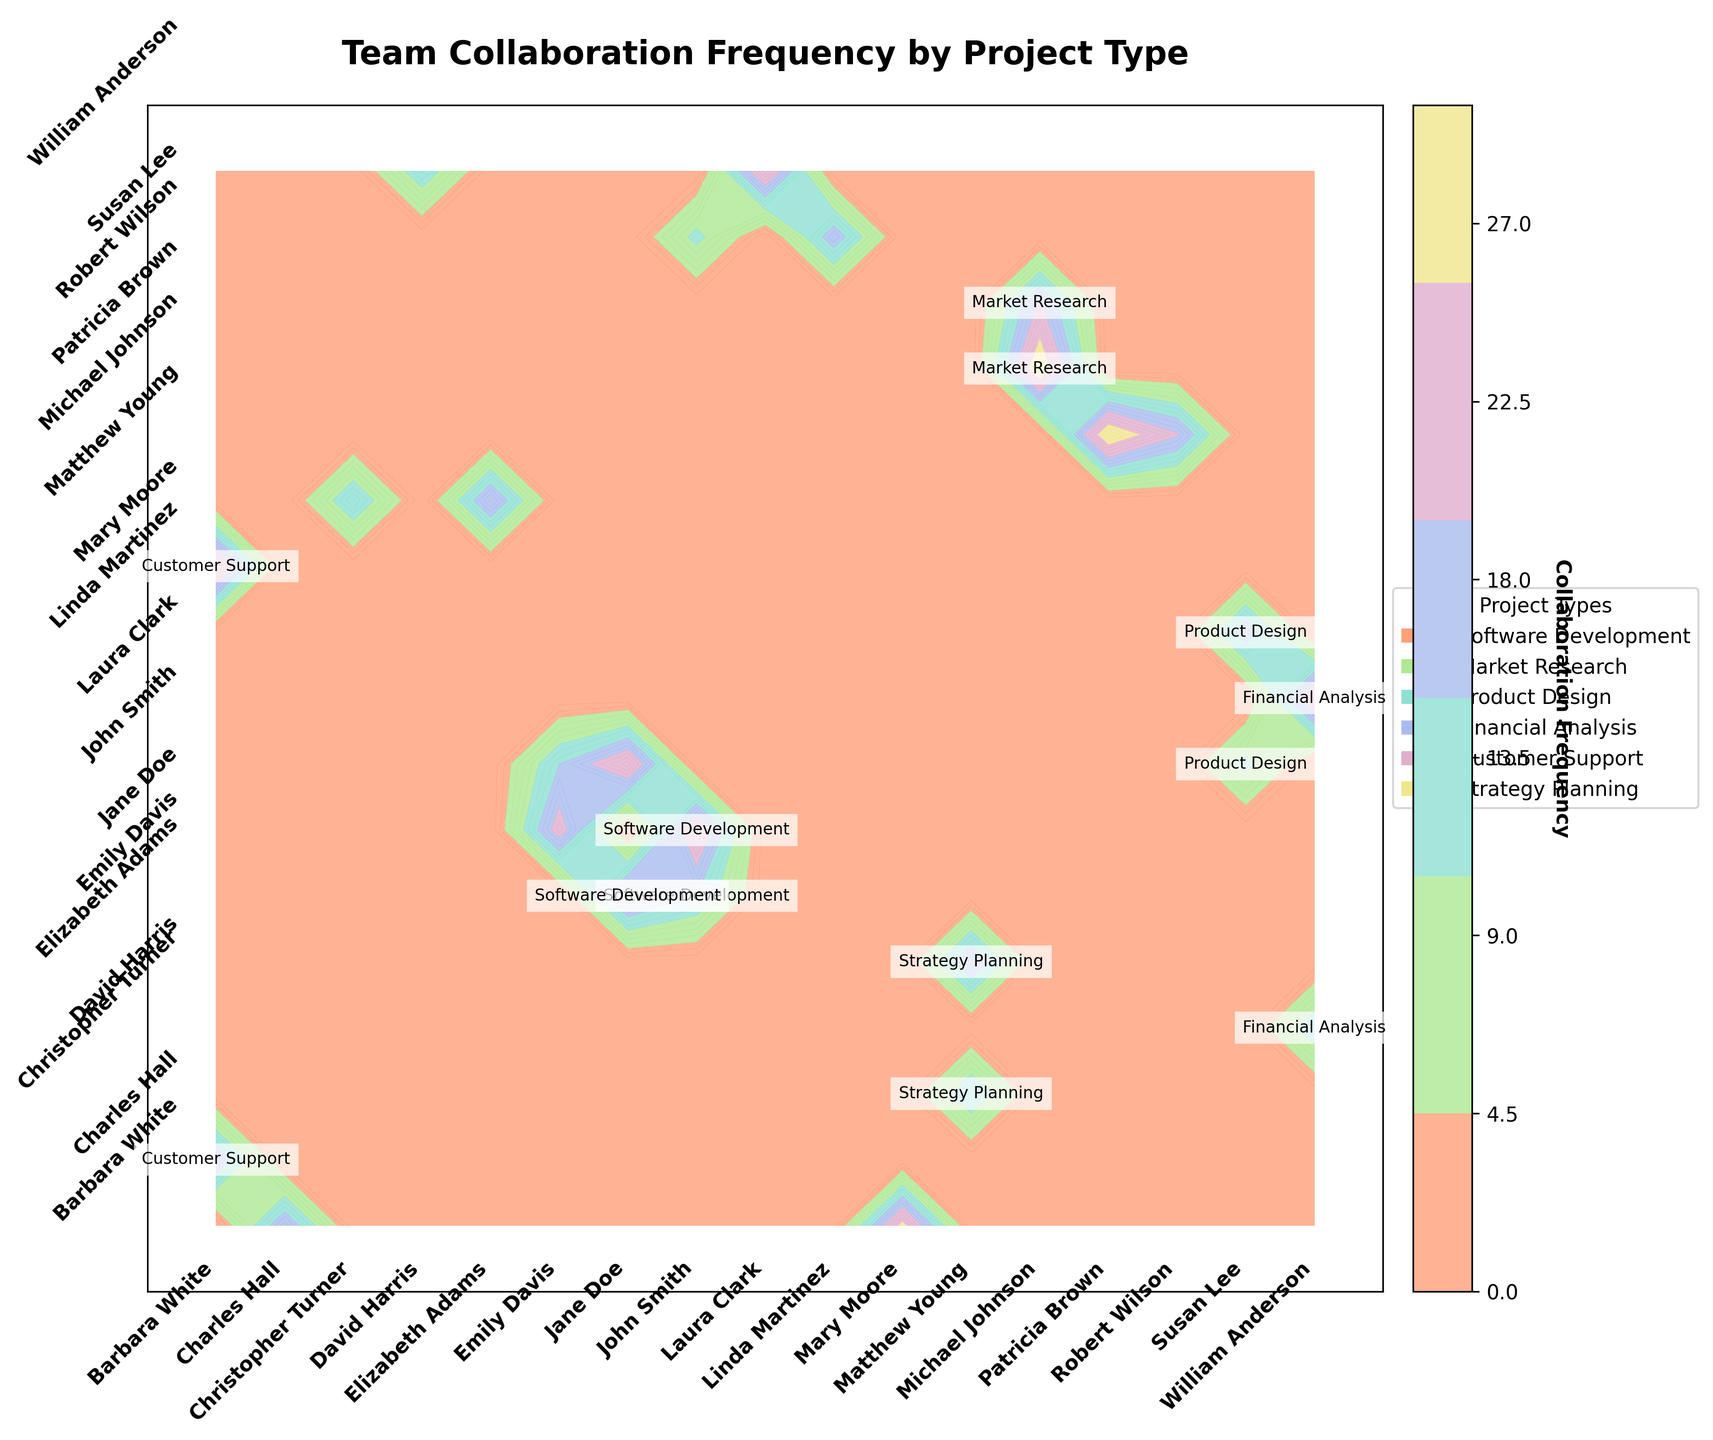What is the title of the figure? The title is usually located at the top of the plot and is often in a larger or bold font style.
Answer: "Team Collaboration Frequency by Project Type" Which team member has the highest collaboration frequency with Jane Doe? Locate Jane Doe on one axis and find the highest value on her row/column. The corresponding team member label on the other axis indicates the team member with the highest frequency.
Answer: John Smith On which project type did Barbara White collaborate with Mary Moore, and what was their collaboration frequency and duration? Locate the intersection of Barbara White and Mary Moore on the plot. The project type label in the cell and corresponding values show the required information.
Answer: Customer Support, 27, 50 hours Which team members participated in the most project types according to the plot? Count the number of project type labels for each team member on the plot by looking at the intersections where they are labeled.
Answer: John Smith and Barbara White How does the collaboration frequency between Michael Johnson and Patricia Brown compare to that between Susan Lee and Linda Martinez? Identify the cells for these pairs and compare the numerical values of their collaboration frequencies.
Answer: Michael Johnson and Patricia Brown's collaboration frequency is higher (30 vs. 18) Which team has the lowest collaboration frequency on a Software Development project? Locate the Software Development project type labels and compare the associated collaboration frequencies.
Answer: John Smith and Emily Davis (15) How many unique project types are represented in the plot? Count the distinct labels that indicate project types within the grid.
Answer: 6 If the total collaboration frequency for John Smith is considered, what is his combined frequency from all projects? Sum the collaboration frequencies for John Smith across all projects.
Answer: 52 (25 + 15 + 12) Identify the team member(s) with whom Matthew Young collaborated on Strategy Planning. Find the intersection of Matthew Young on the plot and look at the project type labels for Strategy Planning.
Answer: Elizabeth Adams and Christopher Turner What can be inferred about the general trend of collaboration frequencies in Market Research compared to Financial Analysis? Examine the collaboration frequencies for Market Research and compare them to those of Financial Analysis. Generally, Market Research seems to have a higher collaboration frequency.
Answer: Market Research has higher collaboration frequencies in general 